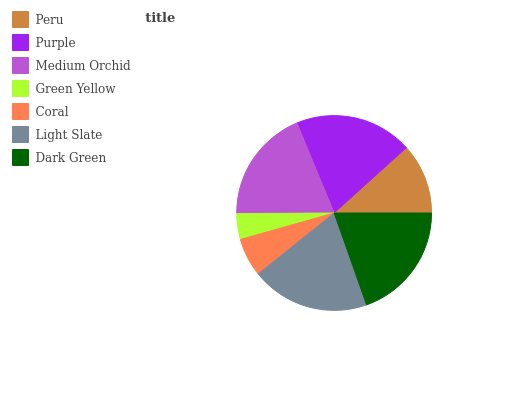Is Green Yellow the minimum?
Answer yes or no. Yes. Is Light Slate the maximum?
Answer yes or no. Yes. Is Purple the minimum?
Answer yes or no. No. Is Purple the maximum?
Answer yes or no. No. Is Purple greater than Peru?
Answer yes or no. Yes. Is Peru less than Purple?
Answer yes or no. Yes. Is Peru greater than Purple?
Answer yes or no. No. Is Purple less than Peru?
Answer yes or no. No. Is Medium Orchid the high median?
Answer yes or no. Yes. Is Medium Orchid the low median?
Answer yes or no. Yes. Is Light Slate the high median?
Answer yes or no. No. Is Light Slate the low median?
Answer yes or no. No. 